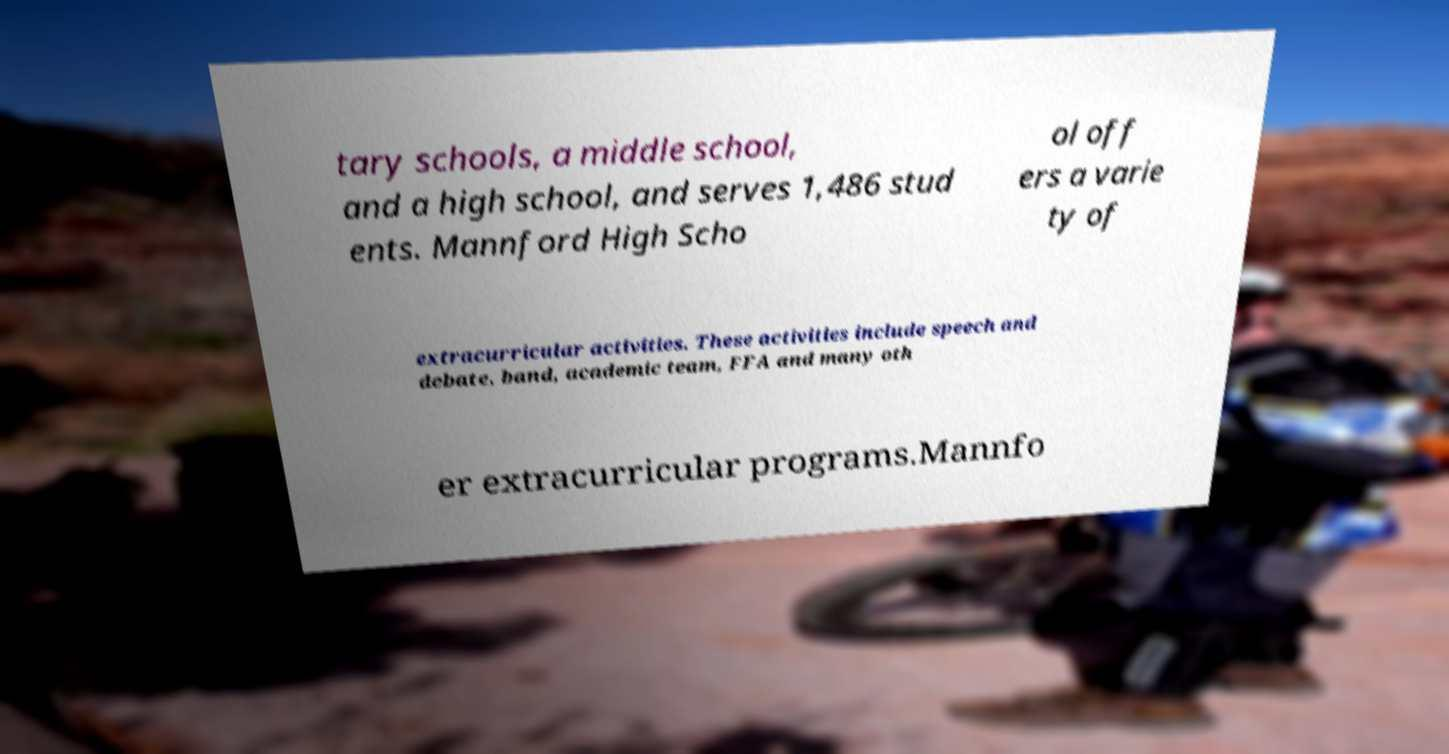Can you accurately transcribe the text from the provided image for me? tary schools, a middle school, and a high school, and serves 1,486 stud ents. Mannford High Scho ol off ers a varie ty of extracurricular activities. These activities include speech and debate, band, academic team, FFA and many oth er extracurricular programs.Mannfo 